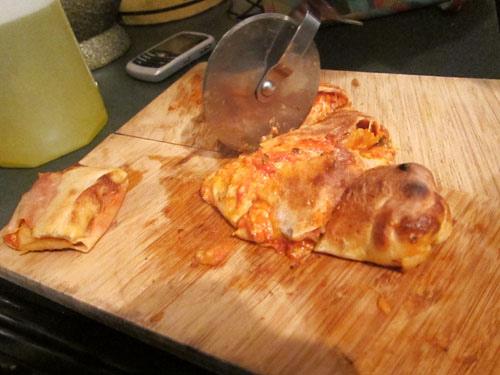How many pieces are there?
Be succinct. 4. Would these foods typically be eaten for lunch?
Be succinct. Yes. Where are the foods?
Write a very short answer. Cutting board. What is being sliced?
Quick response, please. Pizza. What color is the cell phone in the background?
Concise answer only. Silver. 